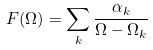<formula> <loc_0><loc_0><loc_500><loc_500>F ( \Omega ) = \sum _ { k } \frac { \alpha _ { k } } { \Omega - \Omega _ { k } }</formula> 